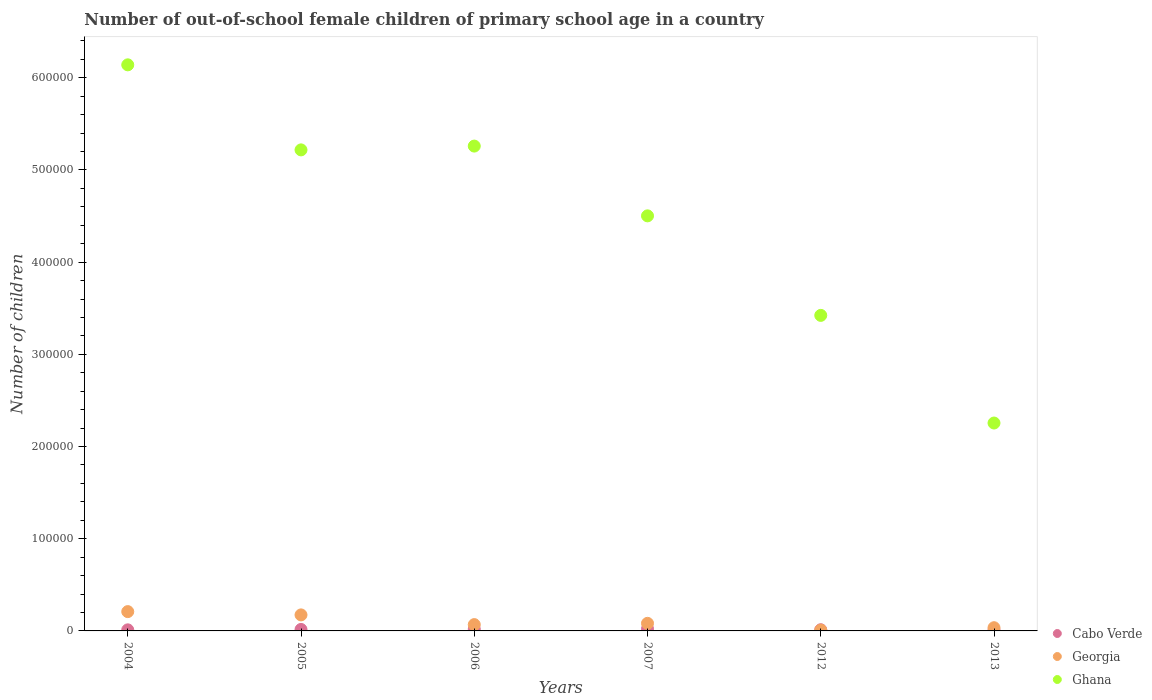What is the number of out-of-school female children in Ghana in 2007?
Ensure brevity in your answer.  4.50e+05. Across all years, what is the maximum number of out-of-school female children in Ghana?
Your answer should be very brief. 6.14e+05. Across all years, what is the minimum number of out-of-school female children in Ghana?
Provide a succinct answer. 2.25e+05. In which year was the number of out-of-school female children in Cabo Verde minimum?
Offer a terse response. 2013. What is the total number of out-of-school female children in Georgia in the graph?
Your answer should be compact. 5.78e+04. What is the difference between the number of out-of-school female children in Georgia in 2004 and that in 2006?
Provide a succinct answer. 1.41e+04. What is the difference between the number of out-of-school female children in Georgia in 2006 and the number of out-of-school female children in Ghana in 2004?
Make the answer very short. -6.07e+05. What is the average number of out-of-school female children in Cabo Verde per year?
Provide a succinct answer. 1539.17. In the year 2012, what is the difference between the number of out-of-school female children in Ghana and number of out-of-school female children in Cabo Verde?
Make the answer very short. 3.41e+05. In how many years, is the number of out-of-school female children in Ghana greater than 480000?
Your answer should be very brief. 3. What is the ratio of the number of out-of-school female children in Cabo Verde in 2005 to that in 2006?
Your answer should be compact. 0.81. What is the difference between the highest and the second highest number of out-of-school female children in Ghana?
Offer a very short reply. 8.81e+04. What is the difference between the highest and the lowest number of out-of-school female children in Ghana?
Keep it short and to the point. 3.89e+05. Does the number of out-of-school female children in Ghana monotonically increase over the years?
Keep it short and to the point. No. Is the number of out-of-school female children in Georgia strictly greater than the number of out-of-school female children in Ghana over the years?
Provide a short and direct response. No. Is the number of out-of-school female children in Ghana strictly less than the number of out-of-school female children in Cabo Verde over the years?
Make the answer very short. No. How many years are there in the graph?
Ensure brevity in your answer.  6. What is the difference between two consecutive major ticks on the Y-axis?
Offer a terse response. 1.00e+05. How many legend labels are there?
Provide a short and direct response. 3. What is the title of the graph?
Your response must be concise. Number of out-of-school female children of primary school age in a country. What is the label or title of the X-axis?
Keep it short and to the point. Years. What is the label or title of the Y-axis?
Provide a short and direct response. Number of children. What is the Number of children in Cabo Verde in 2004?
Give a very brief answer. 1169. What is the Number of children in Georgia in 2004?
Offer a very short reply. 2.09e+04. What is the Number of children in Ghana in 2004?
Provide a succinct answer. 6.14e+05. What is the Number of children in Cabo Verde in 2005?
Offer a terse response. 1599. What is the Number of children of Georgia in 2005?
Offer a very short reply. 1.74e+04. What is the Number of children in Ghana in 2005?
Your answer should be very brief. 5.22e+05. What is the Number of children of Cabo Verde in 2006?
Give a very brief answer. 1975. What is the Number of children in Georgia in 2006?
Make the answer very short. 6851. What is the Number of children in Ghana in 2006?
Offer a terse response. 5.26e+05. What is the Number of children in Cabo Verde in 2007?
Your response must be concise. 2321. What is the Number of children in Georgia in 2007?
Provide a succinct answer. 8229. What is the Number of children of Ghana in 2007?
Your answer should be compact. 4.50e+05. What is the Number of children in Cabo Verde in 2012?
Keep it short and to the point. 1269. What is the Number of children of Georgia in 2012?
Keep it short and to the point. 907. What is the Number of children in Ghana in 2012?
Your answer should be very brief. 3.42e+05. What is the Number of children of Cabo Verde in 2013?
Provide a succinct answer. 902. What is the Number of children of Georgia in 2013?
Give a very brief answer. 3482. What is the Number of children in Ghana in 2013?
Keep it short and to the point. 2.25e+05. Across all years, what is the maximum Number of children of Cabo Verde?
Your answer should be very brief. 2321. Across all years, what is the maximum Number of children of Georgia?
Keep it short and to the point. 2.09e+04. Across all years, what is the maximum Number of children in Ghana?
Give a very brief answer. 6.14e+05. Across all years, what is the minimum Number of children of Cabo Verde?
Ensure brevity in your answer.  902. Across all years, what is the minimum Number of children in Georgia?
Make the answer very short. 907. Across all years, what is the minimum Number of children in Ghana?
Offer a very short reply. 2.25e+05. What is the total Number of children of Cabo Verde in the graph?
Your answer should be compact. 9235. What is the total Number of children in Georgia in the graph?
Keep it short and to the point. 5.78e+04. What is the total Number of children in Ghana in the graph?
Your answer should be very brief. 2.68e+06. What is the difference between the Number of children of Cabo Verde in 2004 and that in 2005?
Your answer should be very brief. -430. What is the difference between the Number of children of Georgia in 2004 and that in 2005?
Your answer should be compact. 3564. What is the difference between the Number of children of Ghana in 2004 and that in 2005?
Make the answer very short. 9.22e+04. What is the difference between the Number of children of Cabo Verde in 2004 and that in 2006?
Provide a succinct answer. -806. What is the difference between the Number of children of Georgia in 2004 and that in 2006?
Provide a short and direct response. 1.41e+04. What is the difference between the Number of children of Ghana in 2004 and that in 2006?
Give a very brief answer. 8.81e+04. What is the difference between the Number of children in Cabo Verde in 2004 and that in 2007?
Your answer should be very brief. -1152. What is the difference between the Number of children of Georgia in 2004 and that in 2007?
Your response must be concise. 1.27e+04. What is the difference between the Number of children of Ghana in 2004 and that in 2007?
Offer a terse response. 1.64e+05. What is the difference between the Number of children in Cabo Verde in 2004 and that in 2012?
Make the answer very short. -100. What is the difference between the Number of children of Georgia in 2004 and that in 2012?
Offer a terse response. 2.00e+04. What is the difference between the Number of children in Ghana in 2004 and that in 2012?
Ensure brevity in your answer.  2.72e+05. What is the difference between the Number of children in Cabo Verde in 2004 and that in 2013?
Offer a very short reply. 267. What is the difference between the Number of children in Georgia in 2004 and that in 2013?
Ensure brevity in your answer.  1.75e+04. What is the difference between the Number of children in Ghana in 2004 and that in 2013?
Ensure brevity in your answer.  3.89e+05. What is the difference between the Number of children in Cabo Verde in 2005 and that in 2006?
Provide a short and direct response. -376. What is the difference between the Number of children in Georgia in 2005 and that in 2006?
Give a very brief answer. 1.05e+04. What is the difference between the Number of children of Ghana in 2005 and that in 2006?
Keep it short and to the point. -4125. What is the difference between the Number of children of Cabo Verde in 2005 and that in 2007?
Your answer should be compact. -722. What is the difference between the Number of children in Georgia in 2005 and that in 2007?
Provide a short and direct response. 9147. What is the difference between the Number of children of Ghana in 2005 and that in 2007?
Provide a short and direct response. 7.16e+04. What is the difference between the Number of children of Cabo Verde in 2005 and that in 2012?
Provide a succinct answer. 330. What is the difference between the Number of children of Georgia in 2005 and that in 2012?
Offer a terse response. 1.65e+04. What is the difference between the Number of children of Ghana in 2005 and that in 2012?
Ensure brevity in your answer.  1.80e+05. What is the difference between the Number of children of Cabo Verde in 2005 and that in 2013?
Ensure brevity in your answer.  697. What is the difference between the Number of children in Georgia in 2005 and that in 2013?
Your response must be concise. 1.39e+04. What is the difference between the Number of children of Ghana in 2005 and that in 2013?
Provide a short and direct response. 2.96e+05. What is the difference between the Number of children in Cabo Verde in 2006 and that in 2007?
Offer a terse response. -346. What is the difference between the Number of children in Georgia in 2006 and that in 2007?
Your answer should be very brief. -1378. What is the difference between the Number of children of Ghana in 2006 and that in 2007?
Offer a very short reply. 7.57e+04. What is the difference between the Number of children of Cabo Verde in 2006 and that in 2012?
Keep it short and to the point. 706. What is the difference between the Number of children in Georgia in 2006 and that in 2012?
Your answer should be compact. 5944. What is the difference between the Number of children in Ghana in 2006 and that in 2012?
Provide a succinct answer. 1.84e+05. What is the difference between the Number of children of Cabo Verde in 2006 and that in 2013?
Provide a short and direct response. 1073. What is the difference between the Number of children of Georgia in 2006 and that in 2013?
Ensure brevity in your answer.  3369. What is the difference between the Number of children in Ghana in 2006 and that in 2013?
Provide a succinct answer. 3.00e+05. What is the difference between the Number of children of Cabo Verde in 2007 and that in 2012?
Keep it short and to the point. 1052. What is the difference between the Number of children in Georgia in 2007 and that in 2012?
Give a very brief answer. 7322. What is the difference between the Number of children of Ghana in 2007 and that in 2012?
Make the answer very short. 1.08e+05. What is the difference between the Number of children of Cabo Verde in 2007 and that in 2013?
Your response must be concise. 1419. What is the difference between the Number of children of Georgia in 2007 and that in 2013?
Make the answer very short. 4747. What is the difference between the Number of children of Ghana in 2007 and that in 2013?
Offer a terse response. 2.25e+05. What is the difference between the Number of children in Cabo Verde in 2012 and that in 2013?
Offer a very short reply. 367. What is the difference between the Number of children in Georgia in 2012 and that in 2013?
Give a very brief answer. -2575. What is the difference between the Number of children in Ghana in 2012 and that in 2013?
Offer a very short reply. 1.17e+05. What is the difference between the Number of children in Cabo Verde in 2004 and the Number of children in Georgia in 2005?
Give a very brief answer. -1.62e+04. What is the difference between the Number of children of Cabo Verde in 2004 and the Number of children of Ghana in 2005?
Give a very brief answer. -5.21e+05. What is the difference between the Number of children of Georgia in 2004 and the Number of children of Ghana in 2005?
Provide a succinct answer. -5.01e+05. What is the difference between the Number of children in Cabo Verde in 2004 and the Number of children in Georgia in 2006?
Keep it short and to the point. -5682. What is the difference between the Number of children of Cabo Verde in 2004 and the Number of children of Ghana in 2006?
Your response must be concise. -5.25e+05. What is the difference between the Number of children in Georgia in 2004 and the Number of children in Ghana in 2006?
Your answer should be compact. -5.05e+05. What is the difference between the Number of children in Cabo Verde in 2004 and the Number of children in Georgia in 2007?
Your response must be concise. -7060. What is the difference between the Number of children of Cabo Verde in 2004 and the Number of children of Ghana in 2007?
Your answer should be very brief. -4.49e+05. What is the difference between the Number of children in Georgia in 2004 and the Number of children in Ghana in 2007?
Make the answer very short. -4.29e+05. What is the difference between the Number of children in Cabo Verde in 2004 and the Number of children in Georgia in 2012?
Your answer should be very brief. 262. What is the difference between the Number of children of Cabo Verde in 2004 and the Number of children of Ghana in 2012?
Offer a very short reply. -3.41e+05. What is the difference between the Number of children in Georgia in 2004 and the Number of children in Ghana in 2012?
Keep it short and to the point. -3.21e+05. What is the difference between the Number of children in Cabo Verde in 2004 and the Number of children in Georgia in 2013?
Provide a short and direct response. -2313. What is the difference between the Number of children of Cabo Verde in 2004 and the Number of children of Ghana in 2013?
Provide a succinct answer. -2.24e+05. What is the difference between the Number of children of Georgia in 2004 and the Number of children of Ghana in 2013?
Keep it short and to the point. -2.05e+05. What is the difference between the Number of children of Cabo Verde in 2005 and the Number of children of Georgia in 2006?
Offer a terse response. -5252. What is the difference between the Number of children of Cabo Verde in 2005 and the Number of children of Ghana in 2006?
Offer a terse response. -5.24e+05. What is the difference between the Number of children of Georgia in 2005 and the Number of children of Ghana in 2006?
Offer a terse response. -5.09e+05. What is the difference between the Number of children in Cabo Verde in 2005 and the Number of children in Georgia in 2007?
Provide a short and direct response. -6630. What is the difference between the Number of children in Cabo Verde in 2005 and the Number of children in Ghana in 2007?
Give a very brief answer. -4.49e+05. What is the difference between the Number of children of Georgia in 2005 and the Number of children of Ghana in 2007?
Your answer should be compact. -4.33e+05. What is the difference between the Number of children of Cabo Verde in 2005 and the Number of children of Georgia in 2012?
Give a very brief answer. 692. What is the difference between the Number of children of Cabo Verde in 2005 and the Number of children of Ghana in 2012?
Keep it short and to the point. -3.41e+05. What is the difference between the Number of children in Georgia in 2005 and the Number of children in Ghana in 2012?
Your response must be concise. -3.25e+05. What is the difference between the Number of children in Cabo Verde in 2005 and the Number of children in Georgia in 2013?
Offer a very short reply. -1883. What is the difference between the Number of children in Cabo Verde in 2005 and the Number of children in Ghana in 2013?
Keep it short and to the point. -2.24e+05. What is the difference between the Number of children in Georgia in 2005 and the Number of children in Ghana in 2013?
Offer a very short reply. -2.08e+05. What is the difference between the Number of children in Cabo Verde in 2006 and the Number of children in Georgia in 2007?
Make the answer very short. -6254. What is the difference between the Number of children in Cabo Verde in 2006 and the Number of children in Ghana in 2007?
Offer a terse response. -4.48e+05. What is the difference between the Number of children of Georgia in 2006 and the Number of children of Ghana in 2007?
Your answer should be compact. -4.43e+05. What is the difference between the Number of children of Cabo Verde in 2006 and the Number of children of Georgia in 2012?
Your answer should be very brief. 1068. What is the difference between the Number of children in Cabo Verde in 2006 and the Number of children in Ghana in 2012?
Provide a succinct answer. -3.40e+05. What is the difference between the Number of children of Georgia in 2006 and the Number of children of Ghana in 2012?
Offer a terse response. -3.35e+05. What is the difference between the Number of children of Cabo Verde in 2006 and the Number of children of Georgia in 2013?
Keep it short and to the point. -1507. What is the difference between the Number of children of Cabo Verde in 2006 and the Number of children of Ghana in 2013?
Offer a terse response. -2.24e+05. What is the difference between the Number of children of Georgia in 2006 and the Number of children of Ghana in 2013?
Your answer should be very brief. -2.19e+05. What is the difference between the Number of children of Cabo Verde in 2007 and the Number of children of Georgia in 2012?
Your response must be concise. 1414. What is the difference between the Number of children in Cabo Verde in 2007 and the Number of children in Ghana in 2012?
Provide a short and direct response. -3.40e+05. What is the difference between the Number of children of Georgia in 2007 and the Number of children of Ghana in 2012?
Your answer should be very brief. -3.34e+05. What is the difference between the Number of children in Cabo Verde in 2007 and the Number of children in Georgia in 2013?
Offer a very short reply. -1161. What is the difference between the Number of children in Cabo Verde in 2007 and the Number of children in Ghana in 2013?
Give a very brief answer. -2.23e+05. What is the difference between the Number of children of Georgia in 2007 and the Number of children of Ghana in 2013?
Make the answer very short. -2.17e+05. What is the difference between the Number of children in Cabo Verde in 2012 and the Number of children in Georgia in 2013?
Provide a short and direct response. -2213. What is the difference between the Number of children of Cabo Verde in 2012 and the Number of children of Ghana in 2013?
Ensure brevity in your answer.  -2.24e+05. What is the difference between the Number of children of Georgia in 2012 and the Number of children of Ghana in 2013?
Your answer should be compact. -2.25e+05. What is the average Number of children in Cabo Verde per year?
Your answer should be very brief. 1539.17. What is the average Number of children of Georgia per year?
Your answer should be compact. 9630.83. What is the average Number of children in Ghana per year?
Make the answer very short. 4.47e+05. In the year 2004, what is the difference between the Number of children in Cabo Verde and Number of children in Georgia?
Your response must be concise. -1.98e+04. In the year 2004, what is the difference between the Number of children of Cabo Verde and Number of children of Ghana?
Your response must be concise. -6.13e+05. In the year 2004, what is the difference between the Number of children in Georgia and Number of children in Ghana?
Offer a terse response. -5.93e+05. In the year 2005, what is the difference between the Number of children in Cabo Verde and Number of children in Georgia?
Ensure brevity in your answer.  -1.58e+04. In the year 2005, what is the difference between the Number of children of Cabo Verde and Number of children of Ghana?
Give a very brief answer. -5.20e+05. In the year 2005, what is the difference between the Number of children in Georgia and Number of children in Ghana?
Your response must be concise. -5.04e+05. In the year 2006, what is the difference between the Number of children in Cabo Verde and Number of children in Georgia?
Offer a very short reply. -4876. In the year 2006, what is the difference between the Number of children in Cabo Verde and Number of children in Ghana?
Ensure brevity in your answer.  -5.24e+05. In the year 2006, what is the difference between the Number of children of Georgia and Number of children of Ghana?
Your response must be concise. -5.19e+05. In the year 2007, what is the difference between the Number of children in Cabo Verde and Number of children in Georgia?
Keep it short and to the point. -5908. In the year 2007, what is the difference between the Number of children in Cabo Verde and Number of children in Ghana?
Your response must be concise. -4.48e+05. In the year 2007, what is the difference between the Number of children of Georgia and Number of children of Ghana?
Offer a terse response. -4.42e+05. In the year 2012, what is the difference between the Number of children in Cabo Verde and Number of children in Georgia?
Provide a succinct answer. 362. In the year 2012, what is the difference between the Number of children of Cabo Verde and Number of children of Ghana?
Give a very brief answer. -3.41e+05. In the year 2012, what is the difference between the Number of children in Georgia and Number of children in Ghana?
Your response must be concise. -3.41e+05. In the year 2013, what is the difference between the Number of children in Cabo Verde and Number of children in Georgia?
Your answer should be very brief. -2580. In the year 2013, what is the difference between the Number of children of Cabo Verde and Number of children of Ghana?
Keep it short and to the point. -2.25e+05. In the year 2013, what is the difference between the Number of children in Georgia and Number of children in Ghana?
Ensure brevity in your answer.  -2.22e+05. What is the ratio of the Number of children of Cabo Verde in 2004 to that in 2005?
Offer a very short reply. 0.73. What is the ratio of the Number of children of Georgia in 2004 to that in 2005?
Your answer should be very brief. 1.21. What is the ratio of the Number of children of Ghana in 2004 to that in 2005?
Give a very brief answer. 1.18. What is the ratio of the Number of children of Cabo Verde in 2004 to that in 2006?
Your answer should be compact. 0.59. What is the ratio of the Number of children in Georgia in 2004 to that in 2006?
Your answer should be compact. 3.06. What is the ratio of the Number of children in Ghana in 2004 to that in 2006?
Ensure brevity in your answer.  1.17. What is the ratio of the Number of children of Cabo Verde in 2004 to that in 2007?
Make the answer very short. 0.5. What is the ratio of the Number of children in Georgia in 2004 to that in 2007?
Offer a very short reply. 2.54. What is the ratio of the Number of children of Ghana in 2004 to that in 2007?
Make the answer very short. 1.36. What is the ratio of the Number of children in Cabo Verde in 2004 to that in 2012?
Provide a short and direct response. 0.92. What is the ratio of the Number of children in Georgia in 2004 to that in 2012?
Your answer should be compact. 23.09. What is the ratio of the Number of children of Ghana in 2004 to that in 2012?
Provide a succinct answer. 1.79. What is the ratio of the Number of children in Cabo Verde in 2004 to that in 2013?
Make the answer very short. 1.3. What is the ratio of the Number of children of Georgia in 2004 to that in 2013?
Provide a succinct answer. 6.01. What is the ratio of the Number of children in Ghana in 2004 to that in 2013?
Your answer should be very brief. 2.72. What is the ratio of the Number of children in Cabo Verde in 2005 to that in 2006?
Make the answer very short. 0.81. What is the ratio of the Number of children of Georgia in 2005 to that in 2006?
Give a very brief answer. 2.54. What is the ratio of the Number of children in Ghana in 2005 to that in 2006?
Your answer should be compact. 0.99. What is the ratio of the Number of children in Cabo Verde in 2005 to that in 2007?
Your answer should be very brief. 0.69. What is the ratio of the Number of children in Georgia in 2005 to that in 2007?
Provide a short and direct response. 2.11. What is the ratio of the Number of children of Ghana in 2005 to that in 2007?
Make the answer very short. 1.16. What is the ratio of the Number of children of Cabo Verde in 2005 to that in 2012?
Offer a terse response. 1.26. What is the ratio of the Number of children of Georgia in 2005 to that in 2012?
Provide a succinct answer. 19.16. What is the ratio of the Number of children of Ghana in 2005 to that in 2012?
Keep it short and to the point. 1.52. What is the ratio of the Number of children in Cabo Verde in 2005 to that in 2013?
Ensure brevity in your answer.  1.77. What is the ratio of the Number of children of Georgia in 2005 to that in 2013?
Ensure brevity in your answer.  4.99. What is the ratio of the Number of children of Ghana in 2005 to that in 2013?
Offer a terse response. 2.31. What is the ratio of the Number of children of Cabo Verde in 2006 to that in 2007?
Your response must be concise. 0.85. What is the ratio of the Number of children of Georgia in 2006 to that in 2007?
Your answer should be compact. 0.83. What is the ratio of the Number of children of Ghana in 2006 to that in 2007?
Give a very brief answer. 1.17. What is the ratio of the Number of children of Cabo Verde in 2006 to that in 2012?
Offer a very short reply. 1.56. What is the ratio of the Number of children of Georgia in 2006 to that in 2012?
Provide a short and direct response. 7.55. What is the ratio of the Number of children in Ghana in 2006 to that in 2012?
Offer a terse response. 1.54. What is the ratio of the Number of children in Cabo Verde in 2006 to that in 2013?
Give a very brief answer. 2.19. What is the ratio of the Number of children in Georgia in 2006 to that in 2013?
Keep it short and to the point. 1.97. What is the ratio of the Number of children of Ghana in 2006 to that in 2013?
Give a very brief answer. 2.33. What is the ratio of the Number of children of Cabo Verde in 2007 to that in 2012?
Offer a very short reply. 1.83. What is the ratio of the Number of children of Georgia in 2007 to that in 2012?
Your response must be concise. 9.07. What is the ratio of the Number of children in Ghana in 2007 to that in 2012?
Give a very brief answer. 1.32. What is the ratio of the Number of children of Cabo Verde in 2007 to that in 2013?
Your response must be concise. 2.57. What is the ratio of the Number of children of Georgia in 2007 to that in 2013?
Offer a terse response. 2.36. What is the ratio of the Number of children of Ghana in 2007 to that in 2013?
Offer a terse response. 2. What is the ratio of the Number of children of Cabo Verde in 2012 to that in 2013?
Your answer should be very brief. 1.41. What is the ratio of the Number of children in Georgia in 2012 to that in 2013?
Provide a succinct answer. 0.26. What is the ratio of the Number of children of Ghana in 2012 to that in 2013?
Your answer should be very brief. 1.52. What is the difference between the highest and the second highest Number of children in Cabo Verde?
Offer a terse response. 346. What is the difference between the highest and the second highest Number of children of Georgia?
Provide a short and direct response. 3564. What is the difference between the highest and the second highest Number of children in Ghana?
Your answer should be compact. 8.81e+04. What is the difference between the highest and the lowest Number of children in Cabo Verde?
Ensure brevity in your answer.  1419. What is the difference between the highest and the lowest Number of children of Georgia?
Make the answer very short. 2.00e+04. What is the difference between the highest and the lowest Number of children of Ghana?
Ensure brevity in your answer.  3.89e+05. 